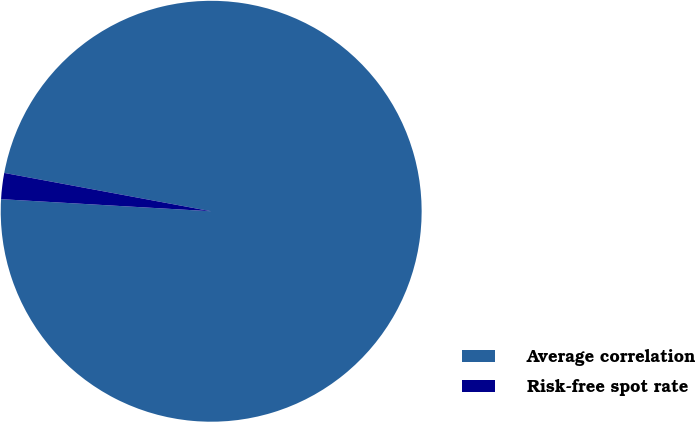Convert chart to OTSL. <chart><loc_0><loc_0><loc_500><loc_500><pie_chart><fcel>Average correlation<fcel>Risk-free spot rate<nl><fcel>98.0%<fcel>2.0%<nl></chart> 